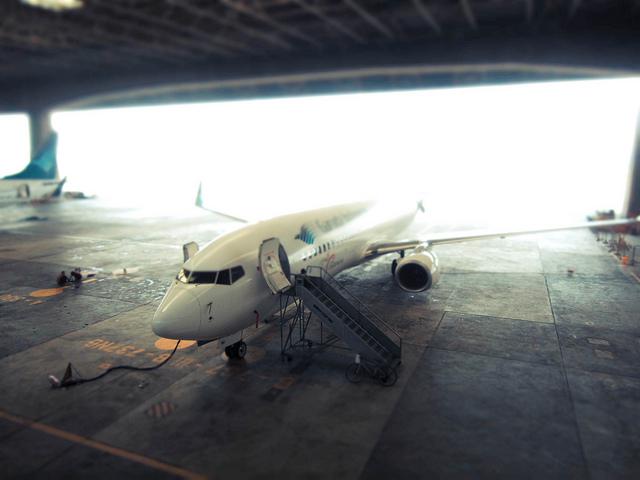To which airline does this plane belong?
Concise answer only. Continental. How many plane engines are visible?
Answer briefly. 1. Are there an stairs?
Give a very brief answer. Yes. Is there a yellow plane?
Short answer required. No. 